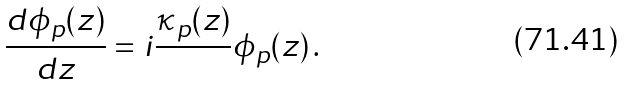<formula> <loc_0><loc_0><loc_500><loc_500>\frac { d \phi _ { p } ( z ) } { d z } = i \frac { \kappa _ { p } ( z ) } { } \phi _ { p } ( z ) \, .</formula> 